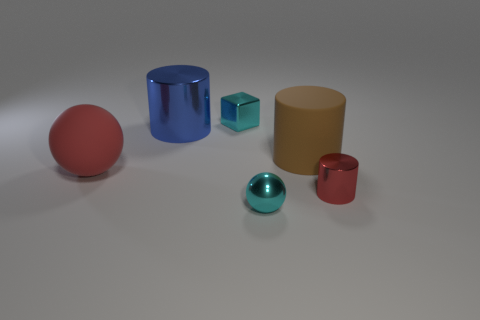Subtract all green balls. Subtract all gray cylinders. How many balls are left? 2 Add 4 big blue cylinders. How many objects exist? 10 Subtract all spheres. How many objects are left? 4 Add 3 red balls. How many red balls are left? 4 Add 1 big red balls. How many big red balls exist? 2 Subtract 1 blue cylinders. How many objects are left? 5 Subtract all tiny gray things. Subtract all blue cylinders. How many objects are left? 5 